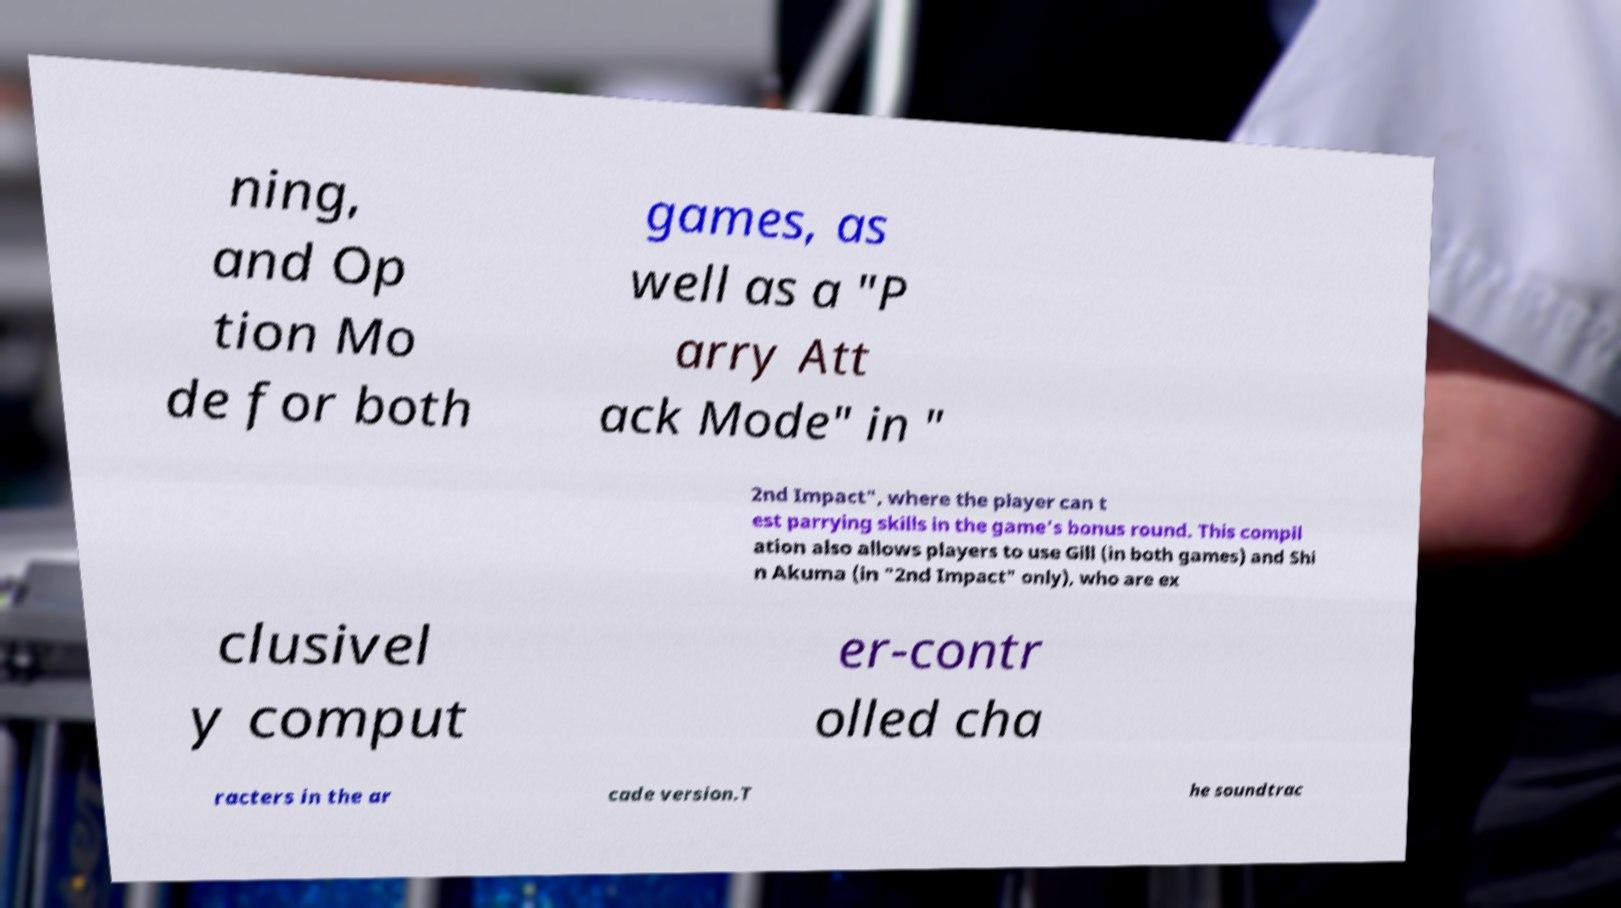Please identify and transcribe the text found in this image. ning, and Op tion Mo de for both games, as well as a "P arry Att ack Mode" in " 2nd Impact", where the player can t est parrying skills in the game's bonus round. This compil ation also allows players to use Gill (in both games) and Shi n Akuma (in "2nd Impact" only), who are ex clusivel y comput er-contr olled cha racters in the ar cade version.T he soundtrac 